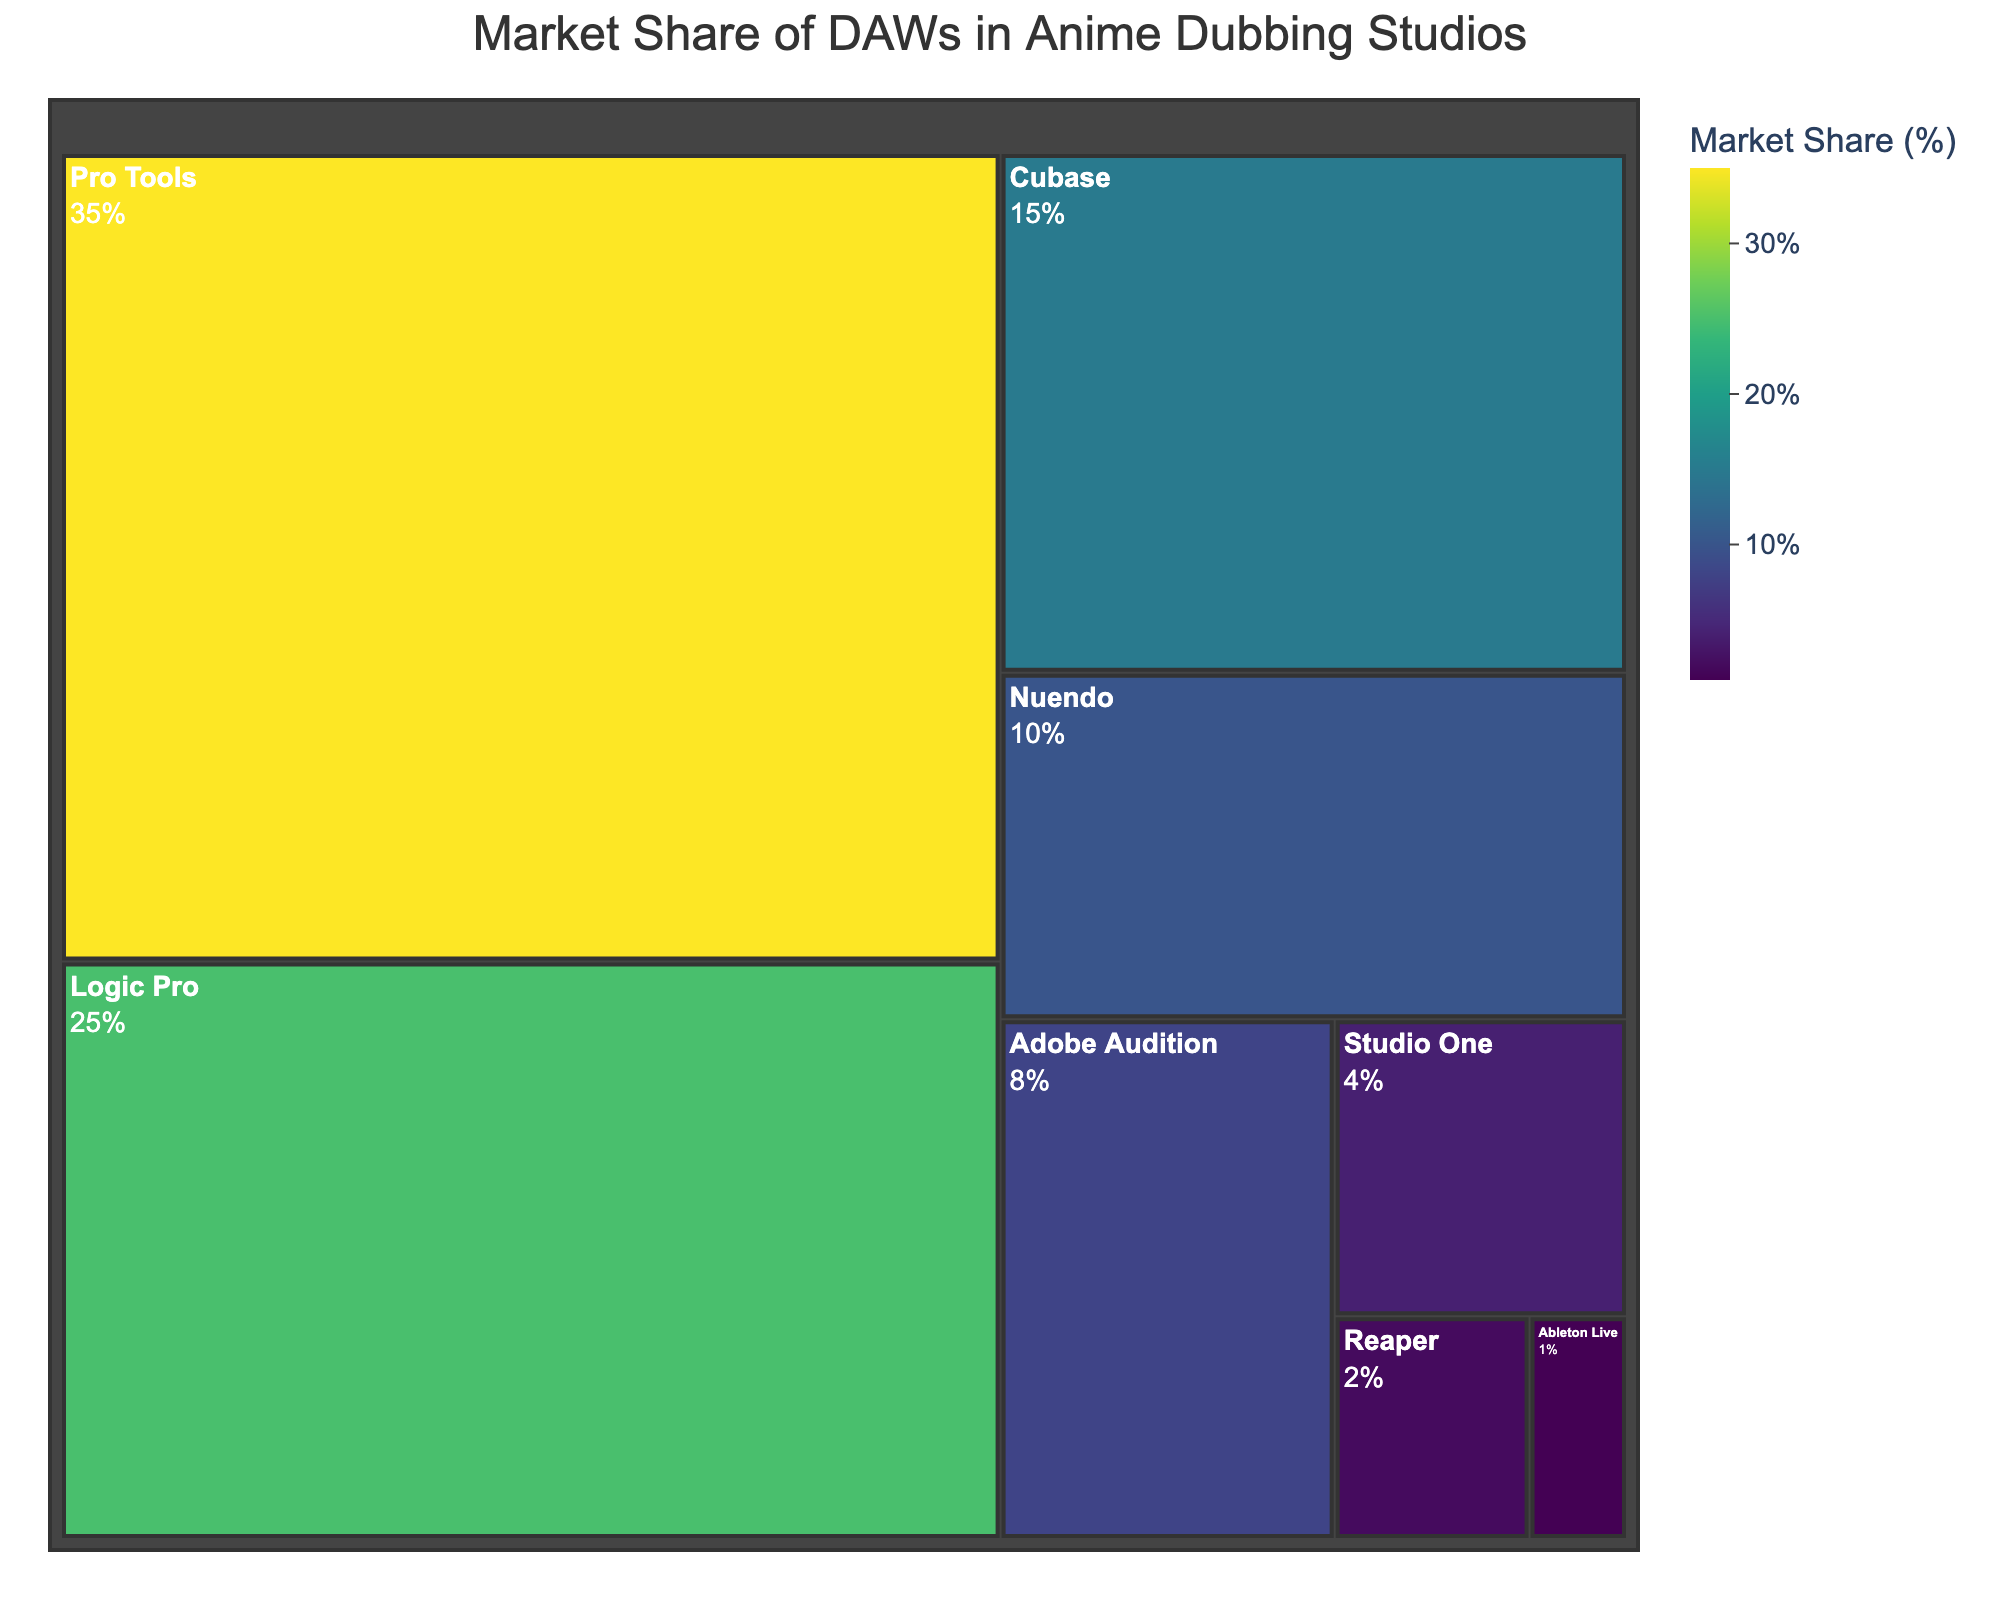Which DAW has the highest market share? The DAW with the biggest section and with the highest market share value in the Treemap is 'Pro Tools' with a 35% market share.
Answer: Pro Tools Which DAWs have a market share greater than 10%? By examining the Treemap, 'Pro Tools' (35%), 'Logic Pro' (25%), and 'Cubase' (15%) each have a market share greater than 10%.
Answer: Pro Tools, Logic Pro, Cubase What is the total market share of Nuendo and Adobe Audition combined? Summing the market shares of Nuendo (10%) and Adobe Audition (8%), we get 10% + 8% = 18%.
Answer: 18% How does Logic Pro's market share compare to Cubase's market share? Logic Pro (25%) has a larger market share than Cubase (15%).
Answer: Logic Pro > Cubase Which DAWs have the smallest market share and what is their combined share? Reaper (2%) and Ableton Live (1%) have the smallest market shares, and their combined share is 2% + 1% = 3%.
Answer: Reaper and Ableton Live, 3% What is the title of the Treemap? The title shown at the top of the Treemap is 'Market Share of DAWs in Anime Dubbing Studios'.
Answer: Market Share of DAWs in Anime Dubbing Studios How many DAWs are represented in the Treemap? Counting the distinct sections in the Treemap, there are 8 DAWs represented.
Answer: 8 What is the difference in market share between the DAW with the highest share and the DAW with the lowest share? Subtracting the lowest share (Ableton Live at 1%) from the highest share (Pro Tools at 35%) gives 35% - 1% = 34%.
Answer: 34% What is the sum of the market shares of Studio One and Reaper? Adding the market shares of Studio One (4%) and Reaper (2%), we get 4% + 2% = 6%.
Answer: 6% What colors are used to represent different market shares in the Treemap? The Treemap uses a color scale from the Viridis color palette, which transitions from blue to yellow-green for different market shares.
Answer: Viridis color scale 